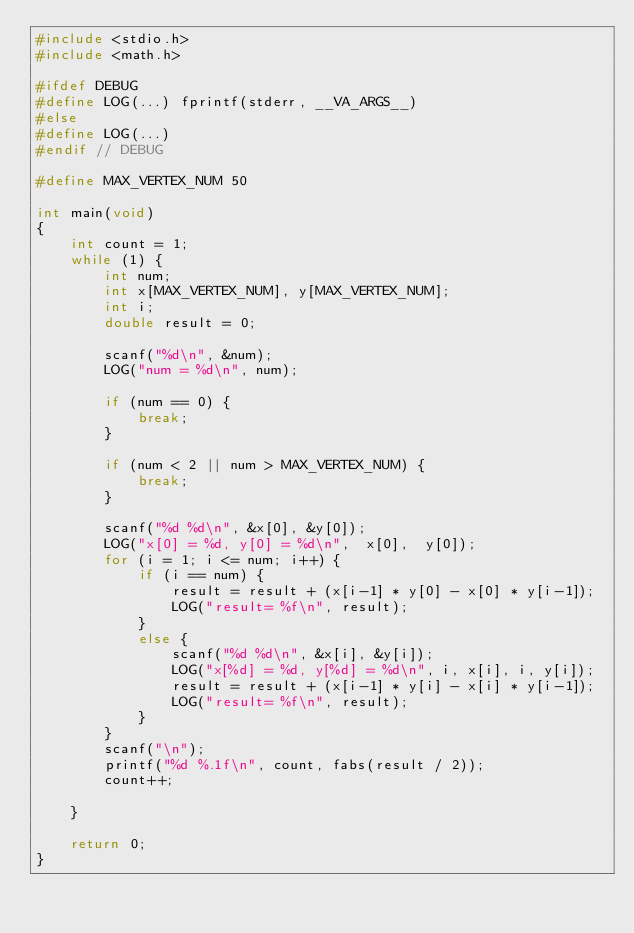Convert code to text. <code><loc_0><loc_0><loc_500><loc_500><_C_>#include <stdio.h>
#include <math.h>

#ifdef DEBUG
#define LOG(...) fprintf(stderr, __VA_ARGS__)
#else
#define LOG(...) 
#endif // DEBUG

#define MAX_VERTEX_NUM 50

int main(void)
{
    int count = 1;
    while (1) {
        int num;
        int x[MAX_VERTEX_NUM], y[MAX_VERTEX_NUM];
        int i;
        double result = 0;
        
        scanf("%d\n", &num);
        LOG("num = %d\n", num);

        if (num == 0) {
            break;
        }

        if (num < 2 || num > MAX_VERTEX_NUM) {
            break;
        }
        
        scanf("%d %d\n", &x[0], &y[0]);
        LOG("x[0] = %d, y[0] = %d\n",  x[0],  y[0]);
        for (i = 1; i <= num; i++) {
            if (i == num) {
                result = result + (x[i-1] * y[0] - x[0] * y[i-1]);
                LOG("result= %f\n", result);
            }
            else {
                scanf("%d %d\n", &x[i], &y[i]);
                LOG("x[%d] = %d, y[%d] = %d\n", i, x[i], i, y[i]);
                result = result + (x[i-1] * y[i] - x[i] * y[i-1]);
                LOG("result= %f\n", result);
            }
        }
        scanf("\n");
        printf("%d %.1f\n", count, fabs(result / 2));
        count++;
                
    }
    
    return 0;
}</code> 